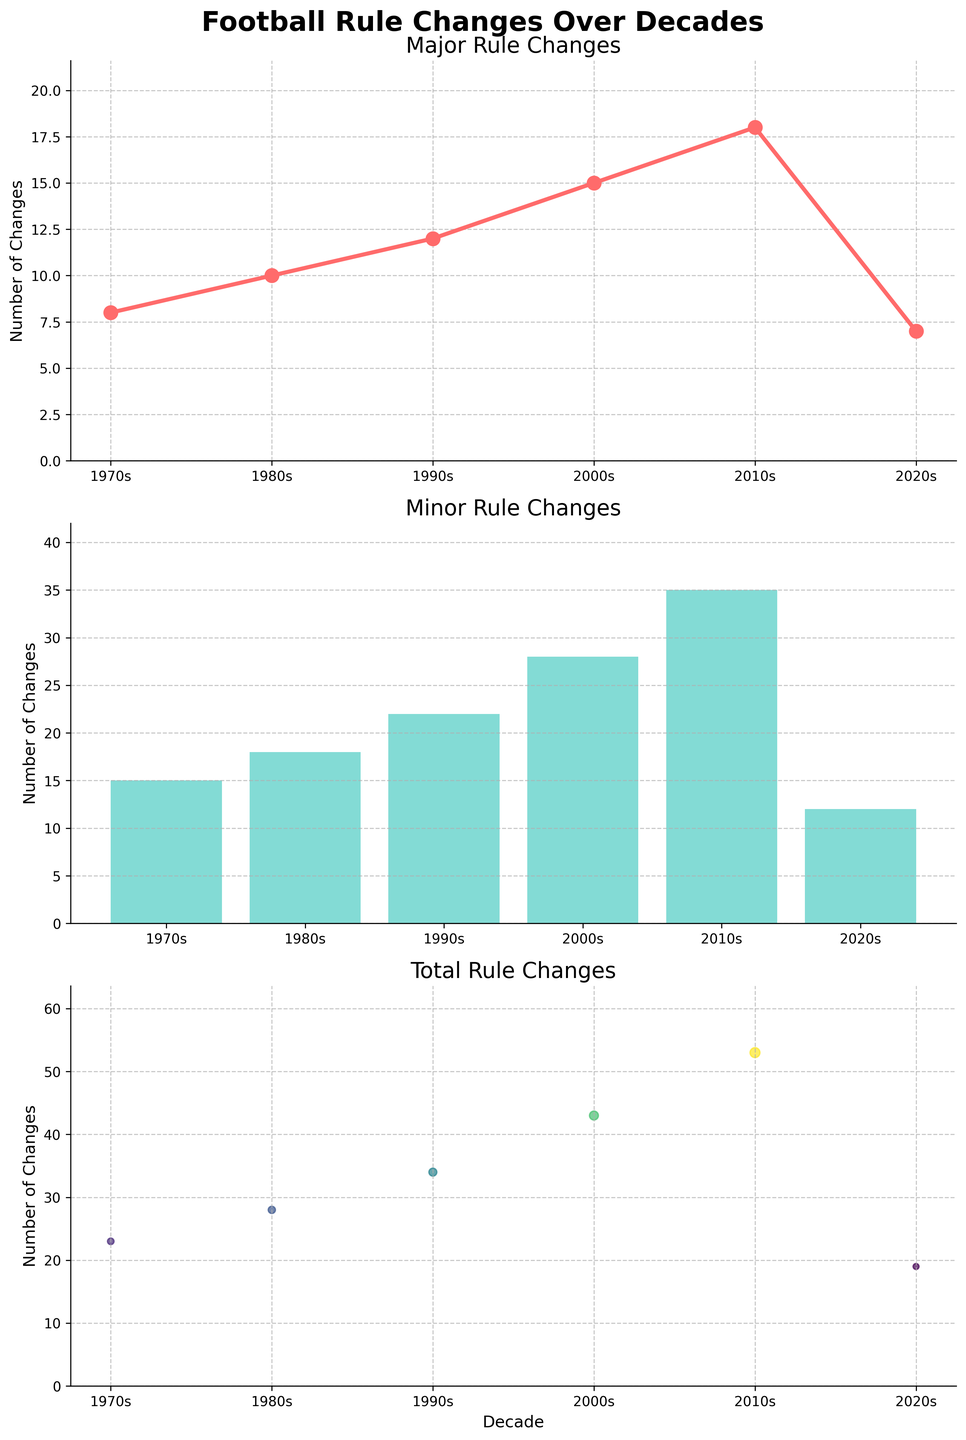What's the total number of major rule changes in the 1990s and 2000s combined? Add the major rule changes for the 1990s and 2000s: 12 (1990s) + 15 (2000s) = 27
Answer: 27 Which decade had the fewest total rule changes for football? Look for the decade with the smallest number in the 'Total Rule Changes' plot. The 2020s had the fewest with 19 rule changes.
Answer: 2020s How does the number of minor rule changes in the 2010s compare to the 1970s? Compare the bar heights for the 2010s and 1970s in the Minor Rule Changes plot. The 2010s had 35 while the 1970s had 15, so the 2010s had 20 more minor changes than the 1970s.
Answer: 20 more What is the difference between the total rule changes in the 2010s and the 1980s? Subtract the total rule changes in the 1980s from those in the 2010s: 53 (2010s) - 28 (1980s) = 25
Answer: 25 During which decades did the major rule changes follow an increasing trend? Look at the peaks and troughs in the Major Rule Changes plot. From the 1970s to the 2010s, the number of major rule changes increased each decade.
Answer: 1970s to 2010s What is the average number of total rule changes per decade from the 1970s to the 2010s? Add the total rule changes and divide by the number of decades: (23 + 28 + 34 + 43 + 53) / 5 = 36.2
Answer: 36.2 Which decade saw the highest number of major rule changes? Identify the decade with the highest point in the Major Rule Changes line plot. The 2010s had the highest number with 18 major changes.
Answer: 2010s How many more minor rule changes were made in the 2000s compared to the 1990s? Subtract the minor rule changes in the 1990s from the 2000s: 28 (2000s) - 22 (1990s) = 6
Answer: 6 What is the total number of rule changes observed across all decades? Sum all the 'Total Rule Changes' from each decade: 23 + 28 + 34 + 43 + 53 + 19 = 200
Answer: 200 In which decade did major and minor rule changes both peak? Look for the decade where both the Major Rule Changes plot and Minor Rule Changes plot have the highest values. The 2010s saw peaks in both major (18) and minor (35) rule changes.
Answer: 2010s 